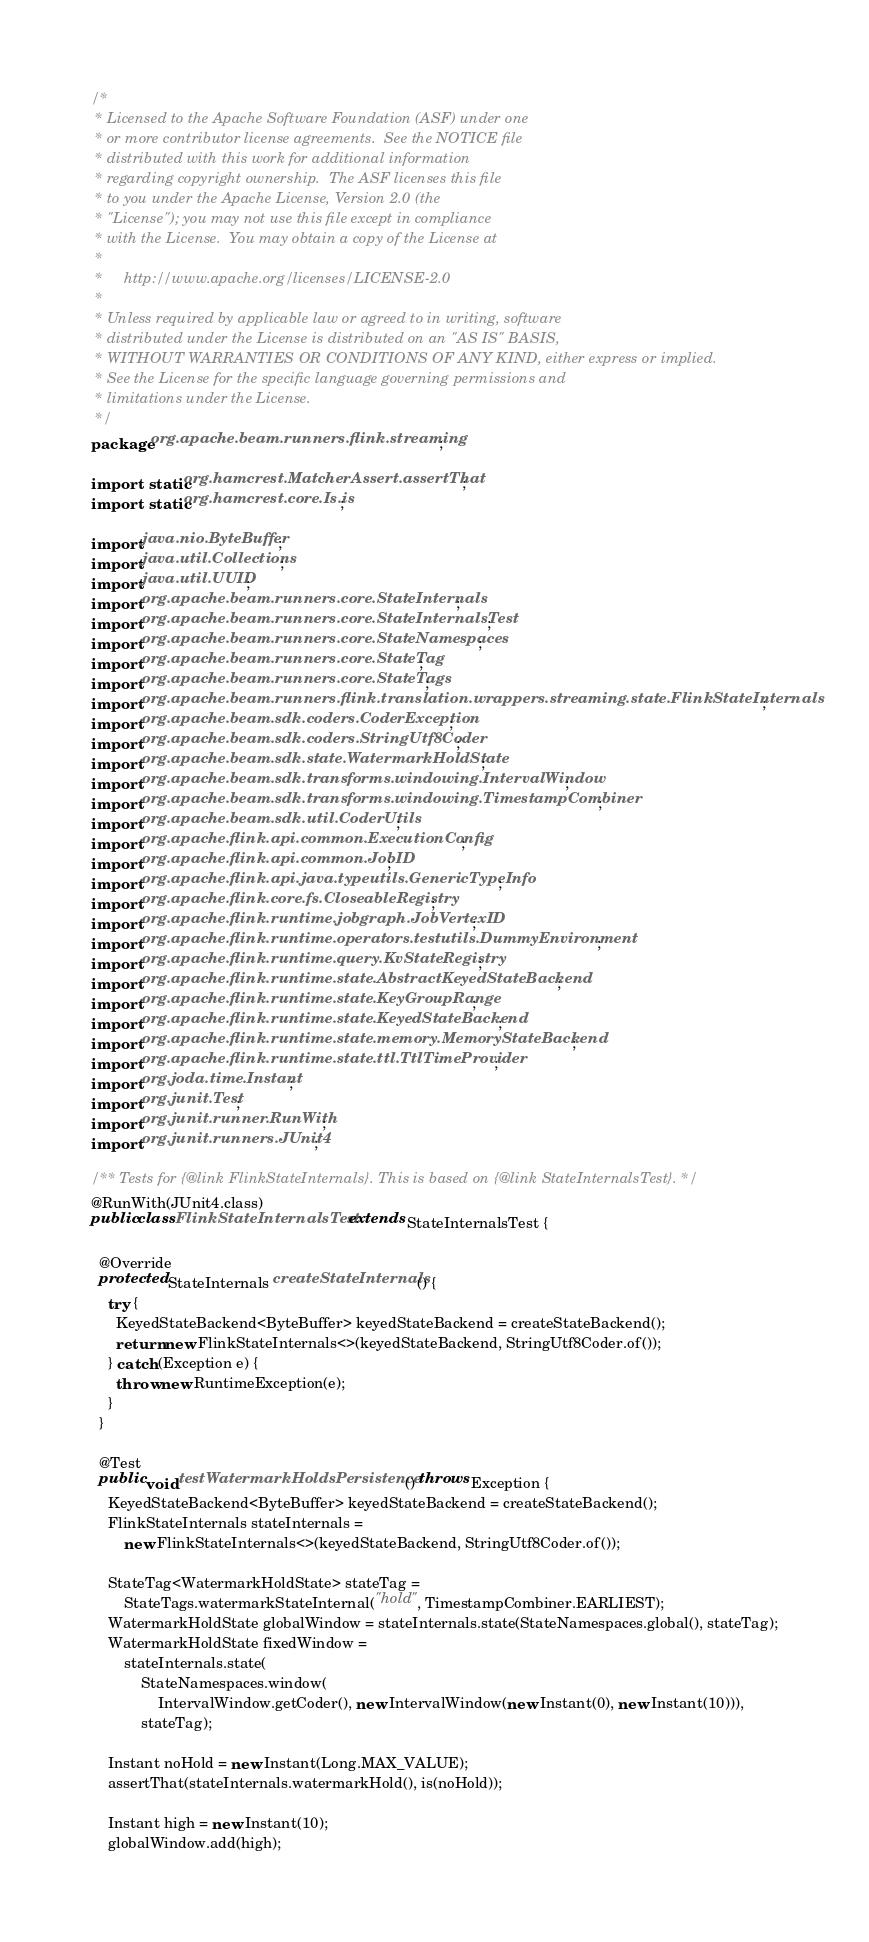<code> <loc_0><loc_0><loc_500><loc_500><_Java_>/*
 * Licensed to the Apache Software Foundation (ASF) under one
 * or more contributor license agreements.  See the NOTICE file
 * distributed with this work for additional information
 * regarding copyright ownership.  The ASF licenses this file
 * to you under the Apache License, Version 2.0 (the
 * "License"); you may not use this file except in compliance
 * with the License.  You may obtain a copy of the License at
 *
 *     http://www.apache.org/licenses/LICENSE-2.0
 *
 * Unless required by applicable law or agreed to in writing, software
 * distributed under the License is distributed on an "AS IS" BASIS,
 * WITHOUT WARRANTIES OR CONDITIONS OF ANY KIND, either express or implied.
 * See the License for the specific language governing permissions and
 * limitations under the License.
 */
package org.apache.beam.runners.flink.streaming;

import static org.hamcrest.MatcherAssert.assertThat;
import static org.hamcrest.core.Is.is;

import java.nio.ByteBuffer;
import java.util.Collections;
import java.util.UUID;
import org.apache.beam.runners.core.StateInternals;
import org.apache.beam.runners.core.StateInternalsTest;
import org.apache.beam.runners.core.StateNamespaces;
import org.apache.beam.runners.core.StateTag;
import org.apache.beam.runners.core.StateTags;
import org.apache.beam.runners.flink.translation.wrappers.streaming.state.FlinkStateInternals;
import org.apache.beam.sdk.coders.CoderException;
import org.apache.beam.sdk.coders.StringUtf8Coder;
import org.apache.beam.sdk.state.WatermarkHoldState;
import org.apache.beam.sdk.transforms.windowing.IntervalWindow;
import org.apache.beam.sdk.transforms.windowing.TimestampCombiner;
import org.apache.beam.sdk.util.CoderUtils;
import org.apache.flink.api.common.ExecutionConfig;
import org.apache.flink.api.common.JobID;
import org.apache.flink.api.java.typeutils.GenericTypeInfo;
import org.apache.flink.core.fs.CloseableRegistry;
import org.apache.flink.runtime.jobgraph.JobVertexID;
import org.apache.flink.runtime.operators.testutils.DummyEnvironment;
import org.apache.flink.runtime.query.KvStateRegistry;
import org.apache.flink.runtime.state.AbstractKeyedStateBackend;
import org.apache.flink.runtime.state.KeyGroupRange;
import org.apache.flink.runtime.state.KeyedStateBackend;
import org.apache.flink.runtime.state.memory.MemoryStateBackend;
import org.apache.flink.runtime.state.ttl.TtlTimeProvider;
import org.joda.time.Instant;
import org.junit.Test;
import org.junit.runner.RunWith;
import org.junit.runners.JUnit4;

/** Tests for {@link FlinkStateInternals}. This is based on {@link StateInternalsTest}. */
@RunWith(JUnit4.class)
public class FlinkStateInternalsTest extends StateInternalsTest {

  @Override
  protected StateInternals createStateInternals() {
    try {
      KeyedStateBackend<ByteBuffer> keyedStateBackend = createStateBackend();
      return new FlinkStateInternals<>(keyedStateBackend, StringUtf8Coder.of());
    } catch (Exception e) {
      throw new RuntimeException(e);
    }
  }

  @Test
  public void testWatermarkHoldsPersistence() throws Exception {
    KeyedStateBackend<ByteBuffer> keyedStateBackend = createStateBackend();
    FlinkStateInternals stateInternals =
        new FlinkStateInternals<>(keyedStateBackend, StringUtf8Coder.of());

    StateTag<WatermarkHoldState> stateTag =
        StateTags.watermarkStateInternal("hold", TimestampCombiner.EARLIEST);
    WatermarkHoldState globalWindow = stateInternals.state(StateNamespaces.global(), stateTag);
    WatermarkHoldState fixedWindow =
        stateInternals.state(
            StateNamespaces.window(
                IntervalWindow.getCoder(), new IntervalWindow(new Instant(0), new Instant(10))),
            stateTag);

    Instant noHold = new Instant(Long.MAX_VALUE);
    assertThat(stateInternals.watermarkHold(), is(noHold));

    Instant high = new Instant(10);
    globalWindow.add(high);</code> 